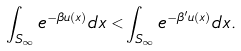Convert formula to latex. <formula><loc_0><loc_0><loc_500><loc_500>\int _ { S _ { \infty } } e ^ { - \beta u ( x ) } d x < \int _ { S _ { \infty } } e ^ { - \beta ^ { \prime } u ( x ) } d x .</formula> 